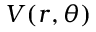<formula> <loc_0><loc_0><loc_500><loc_500>V ( r , \theta )</formula> 